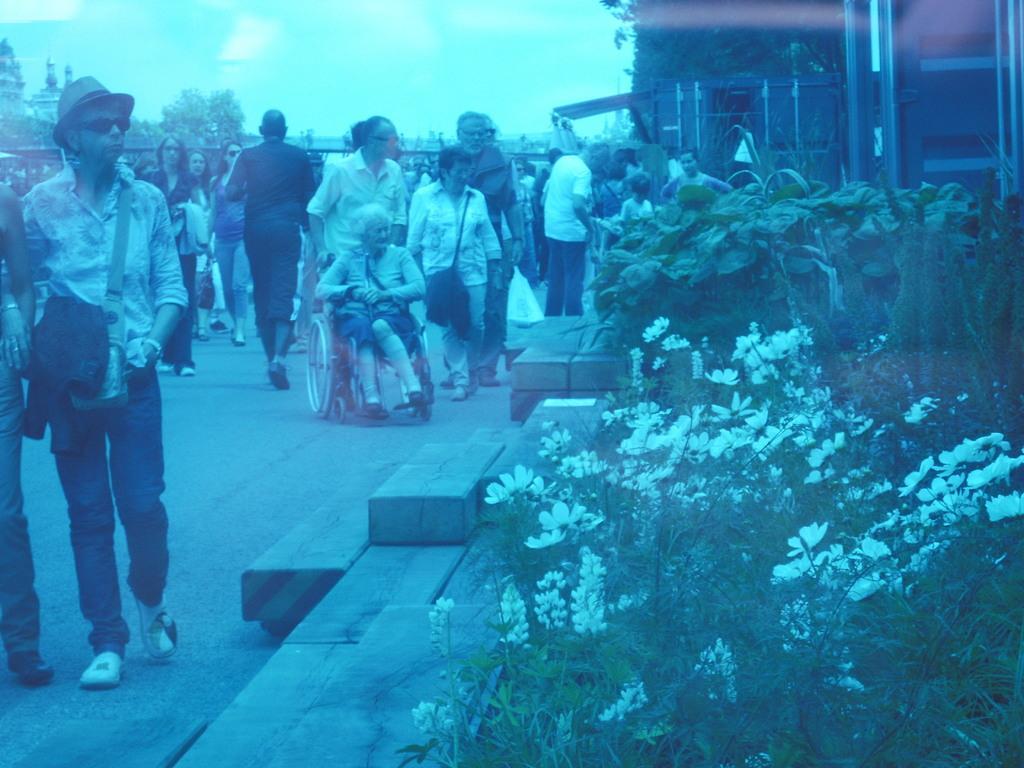In one or two sentences, can you explain what this image depicts? In this image we can see group of persons standing on the ground. One person is wearing, hat and goggles are carrying a bag. In the center of the image we can see a woman sitting in a wheelchair. On the right side of the image we can see group of flowers on plants. In the background, we can see containers, group of trees and the sky. 